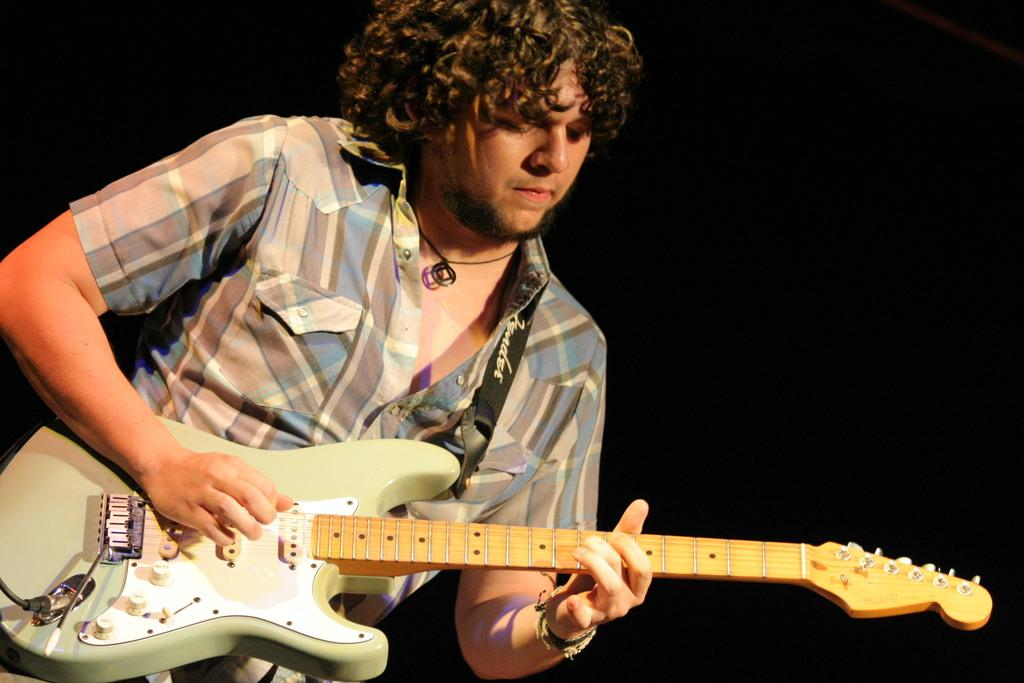What is the main subject of the image? There is a person in the image. What is the person doing in the image? The person is playing a guitar. Can you see any boats at the seashore in the image? There is no seashore or boats present in the image; it features a person playing a guitar. What type of top is the person wearing in the image? The image does not provide enough detail to determine the type of top the person is wearing. 